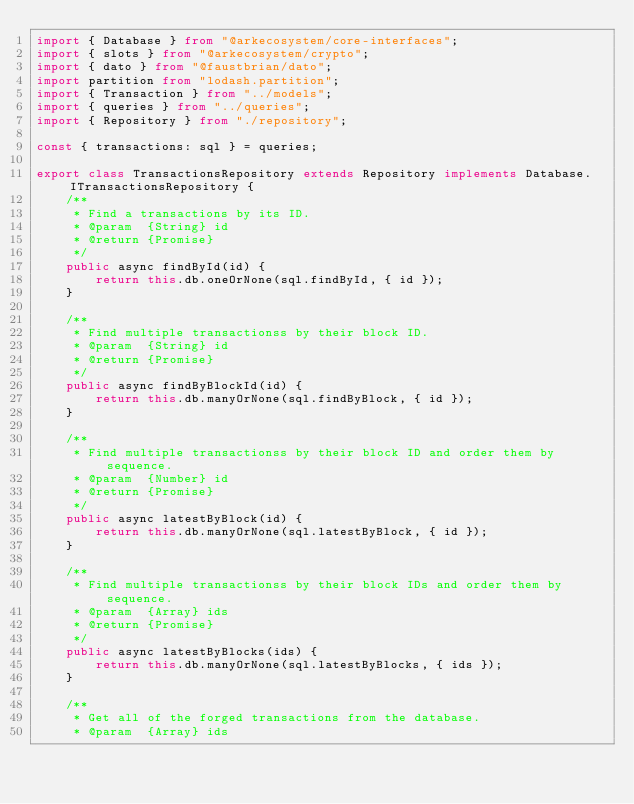<code> <loc_0><loc_0><loc_500><loc_500><_TypeScript_>import { Database } from "@arkecosystem/core-interfaces";
import { slots } from "@arkecosystem/crypto";
import { dato } from "@faustbrian/dato";
import partition from "lodash.partition";
import { Transaction } from "../models";
import { queries } from "../queries";
import { Repository } from "./repository";

const { transactions: sql } = queries;

export class TransactionsRepository extends Repository implements Database.ITransactionsRepository {
    /**
     * Find a transactions by its ID.
     * @param  {String} id
     * @return {Promise}
     */
    public async findById(id) {
        return this.db.oneOrNone(sql.findById, { id });
    }

    /**
     * Find multiple transactionss by their block ID.
     * @param  {String} id
     * @return {Promise}
     */
    public async findByBlockId(id) {
        return this.db.manyOrNone(sql.findByBlock, { id });
    }

    /**
     * Find multiple transactionss by their block ID and order them by sequence.
     * @param  {Number} id
     * @return {Promise}
     */
    public async latestByBlock(id) {
        return this.db.manyOrNone(sql.latestByBlock, { id });
    }

    /**
     * Find multiple transactionss by their block IDs and order them by sequence.
     * @param  {Array} ids
     * @return {Promise}
     */
    public async latestByBlocks(ids) {
        return this.db.manyOrNone(sql.latestByBlocks, { ids });
    }

    /**
     * Get all of the forged transactions from the database.
     * @param  {Array} ids</code> 